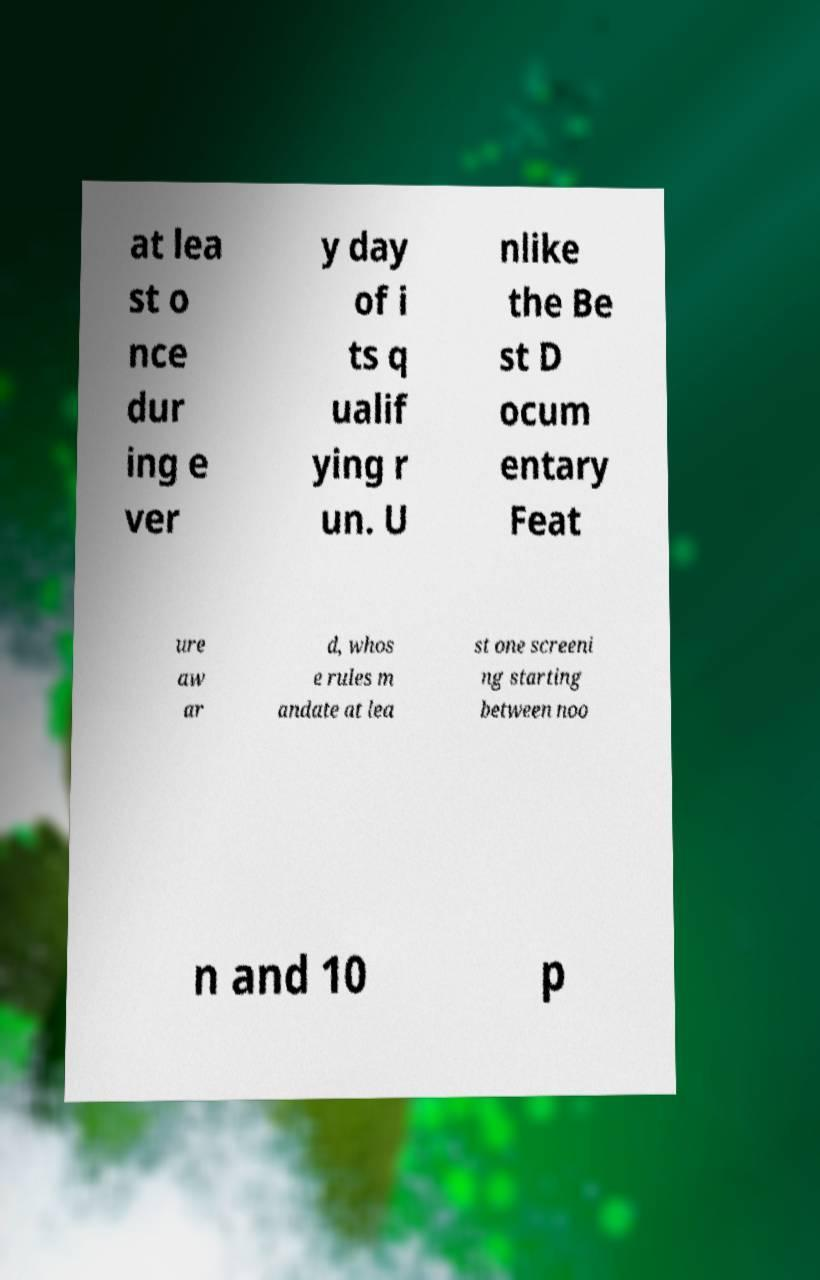Please identify and transcribe the text found in this image. at lea st o nce dur ing e ver y day of i ts q ualif ying r un. U nlike the Be st D ocum entary Feat ure aw ar d, whos e rules m andate at lea st one screeni ng starting between noo n and 10 p 